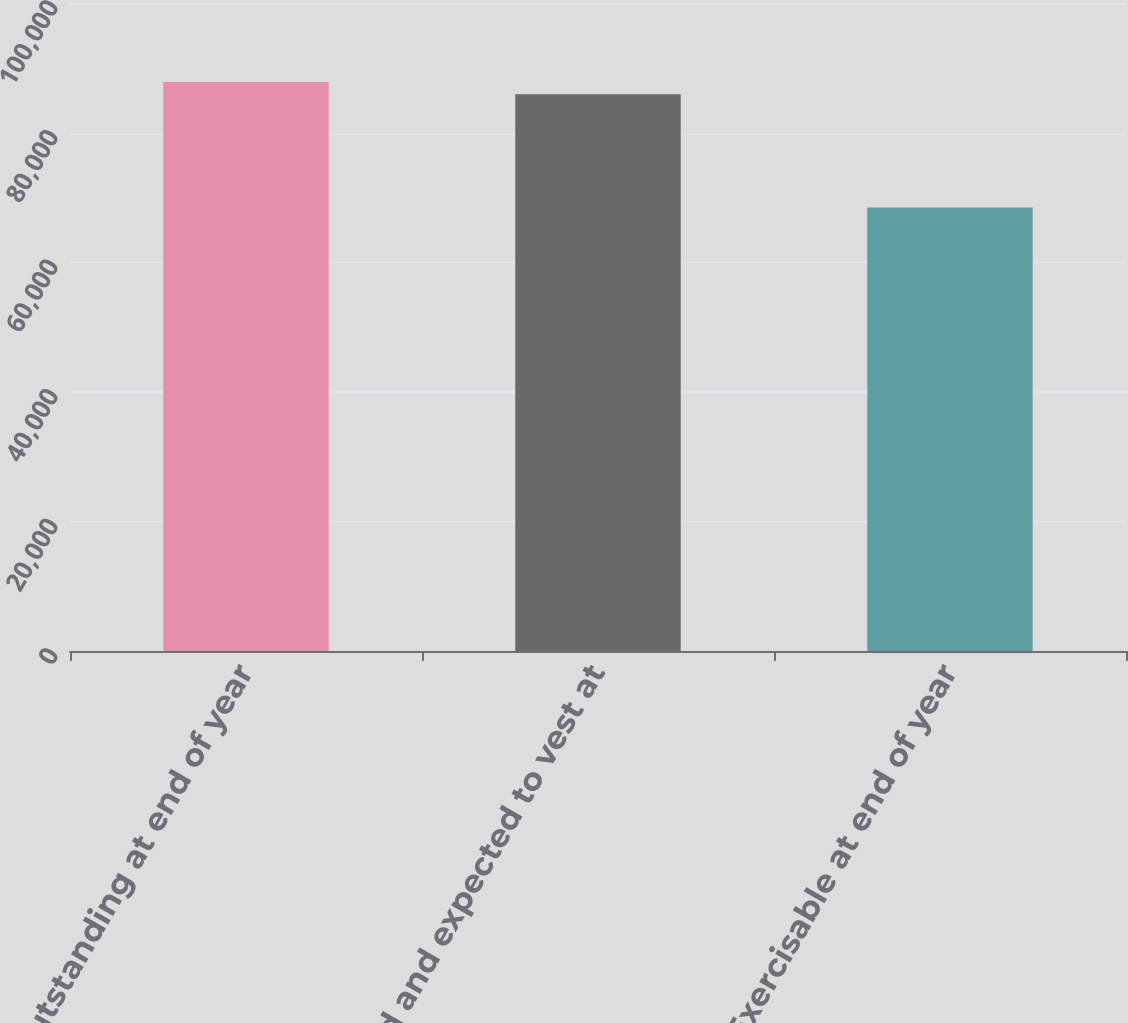<chart> <loc_0><loc_0><loc_500><loc_500><bar_chart><fcel>Outstanding at end of year<fcel>Vested and expected to vest at<fcel>Exercisable at end of year<nl><fcel>87820.9<fcel>85935<fcel>68437<nl></chart> 